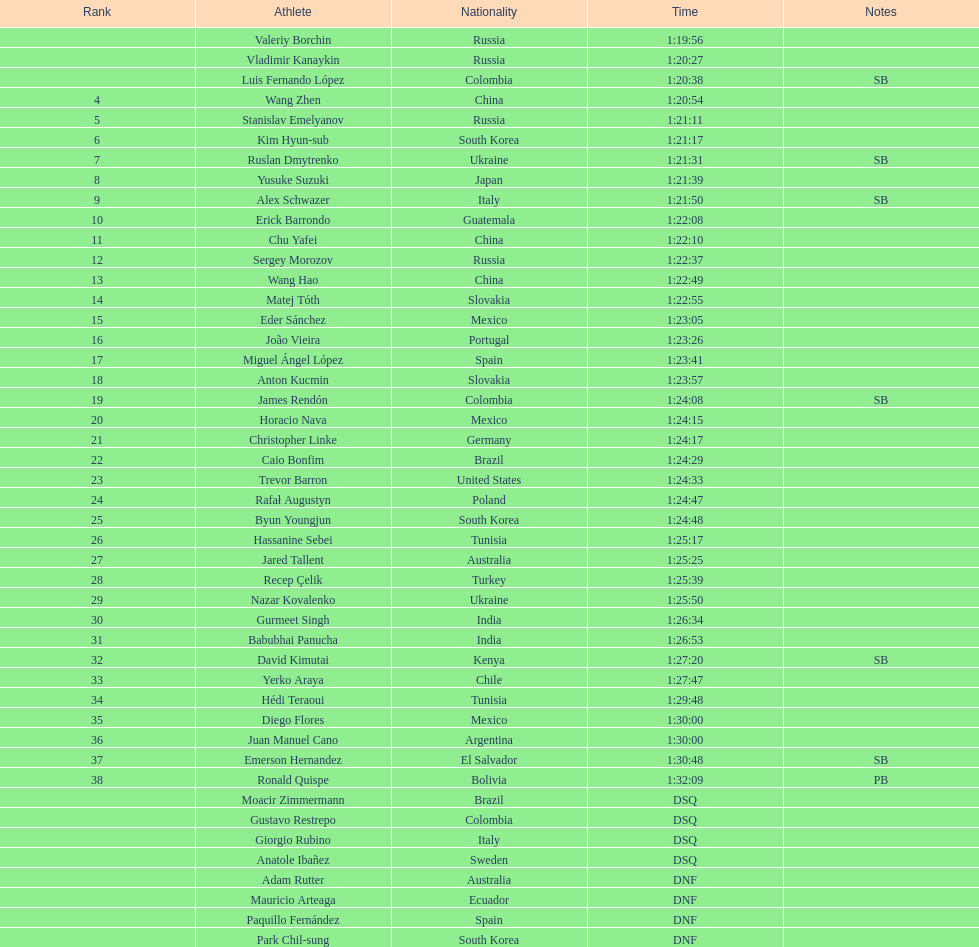Which athlete had the fastest time for the 20km? Valeriy Borchin. 